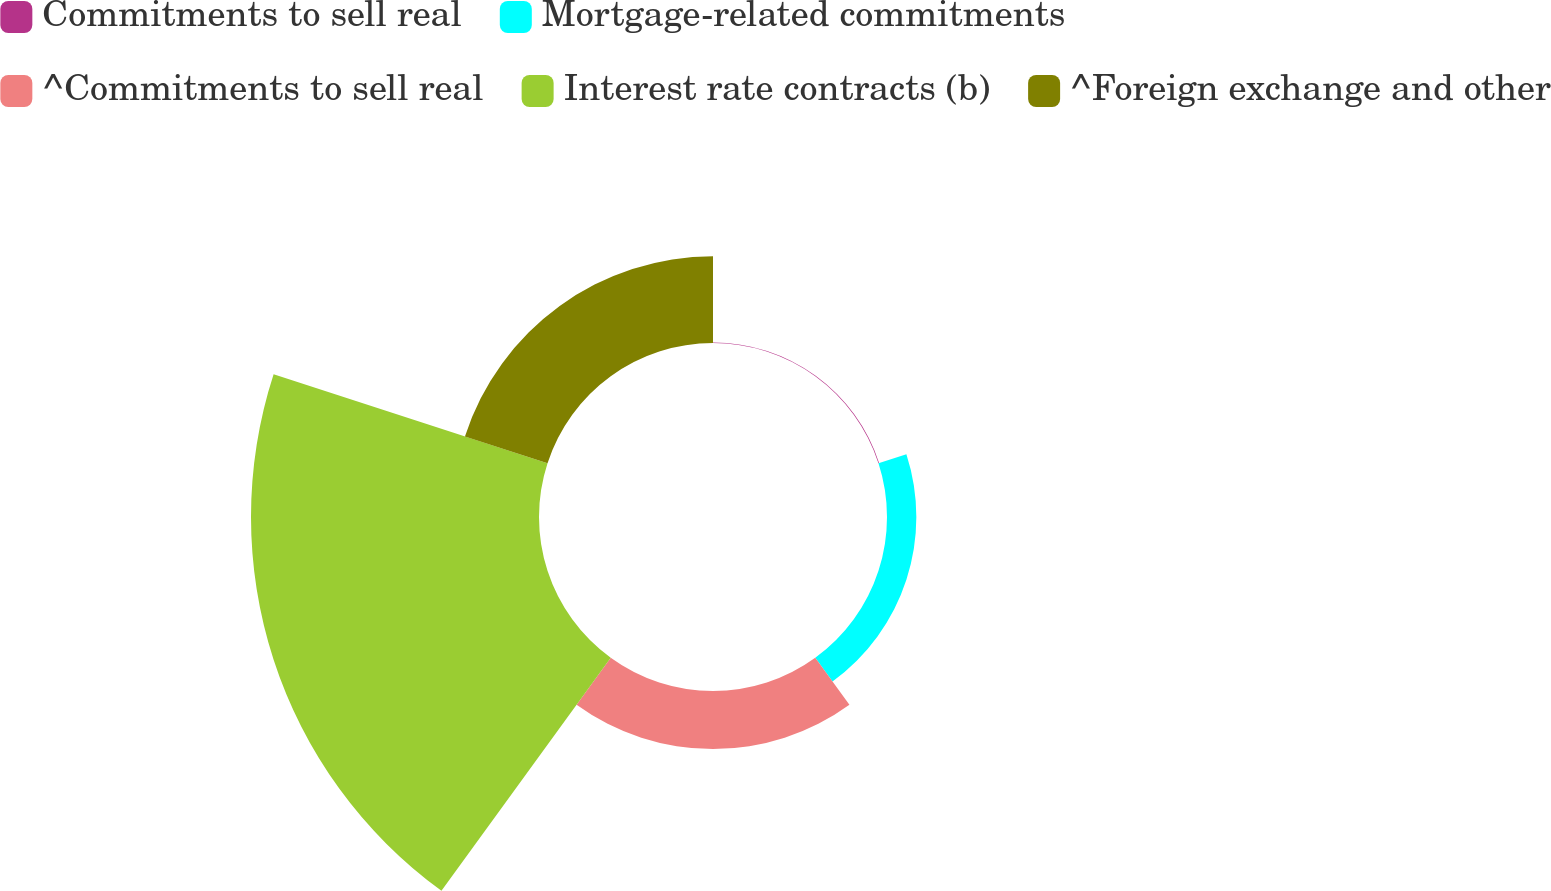Convert chart. <chart><loc_0><loc_0><loc_500><loc_500><pie_chart><fcel>Commitments to sell real<fcel>Mortgage-related commitments<fcel>^Commitments to sell real<fcel>Interest rate contracts (b)<fcel>^Foreign exchange and other<nl><fcel>0.13%<fcel>6.34%<fcel>12.55%<fcel>62.22%<fcel>18.76%<nl></chart> 